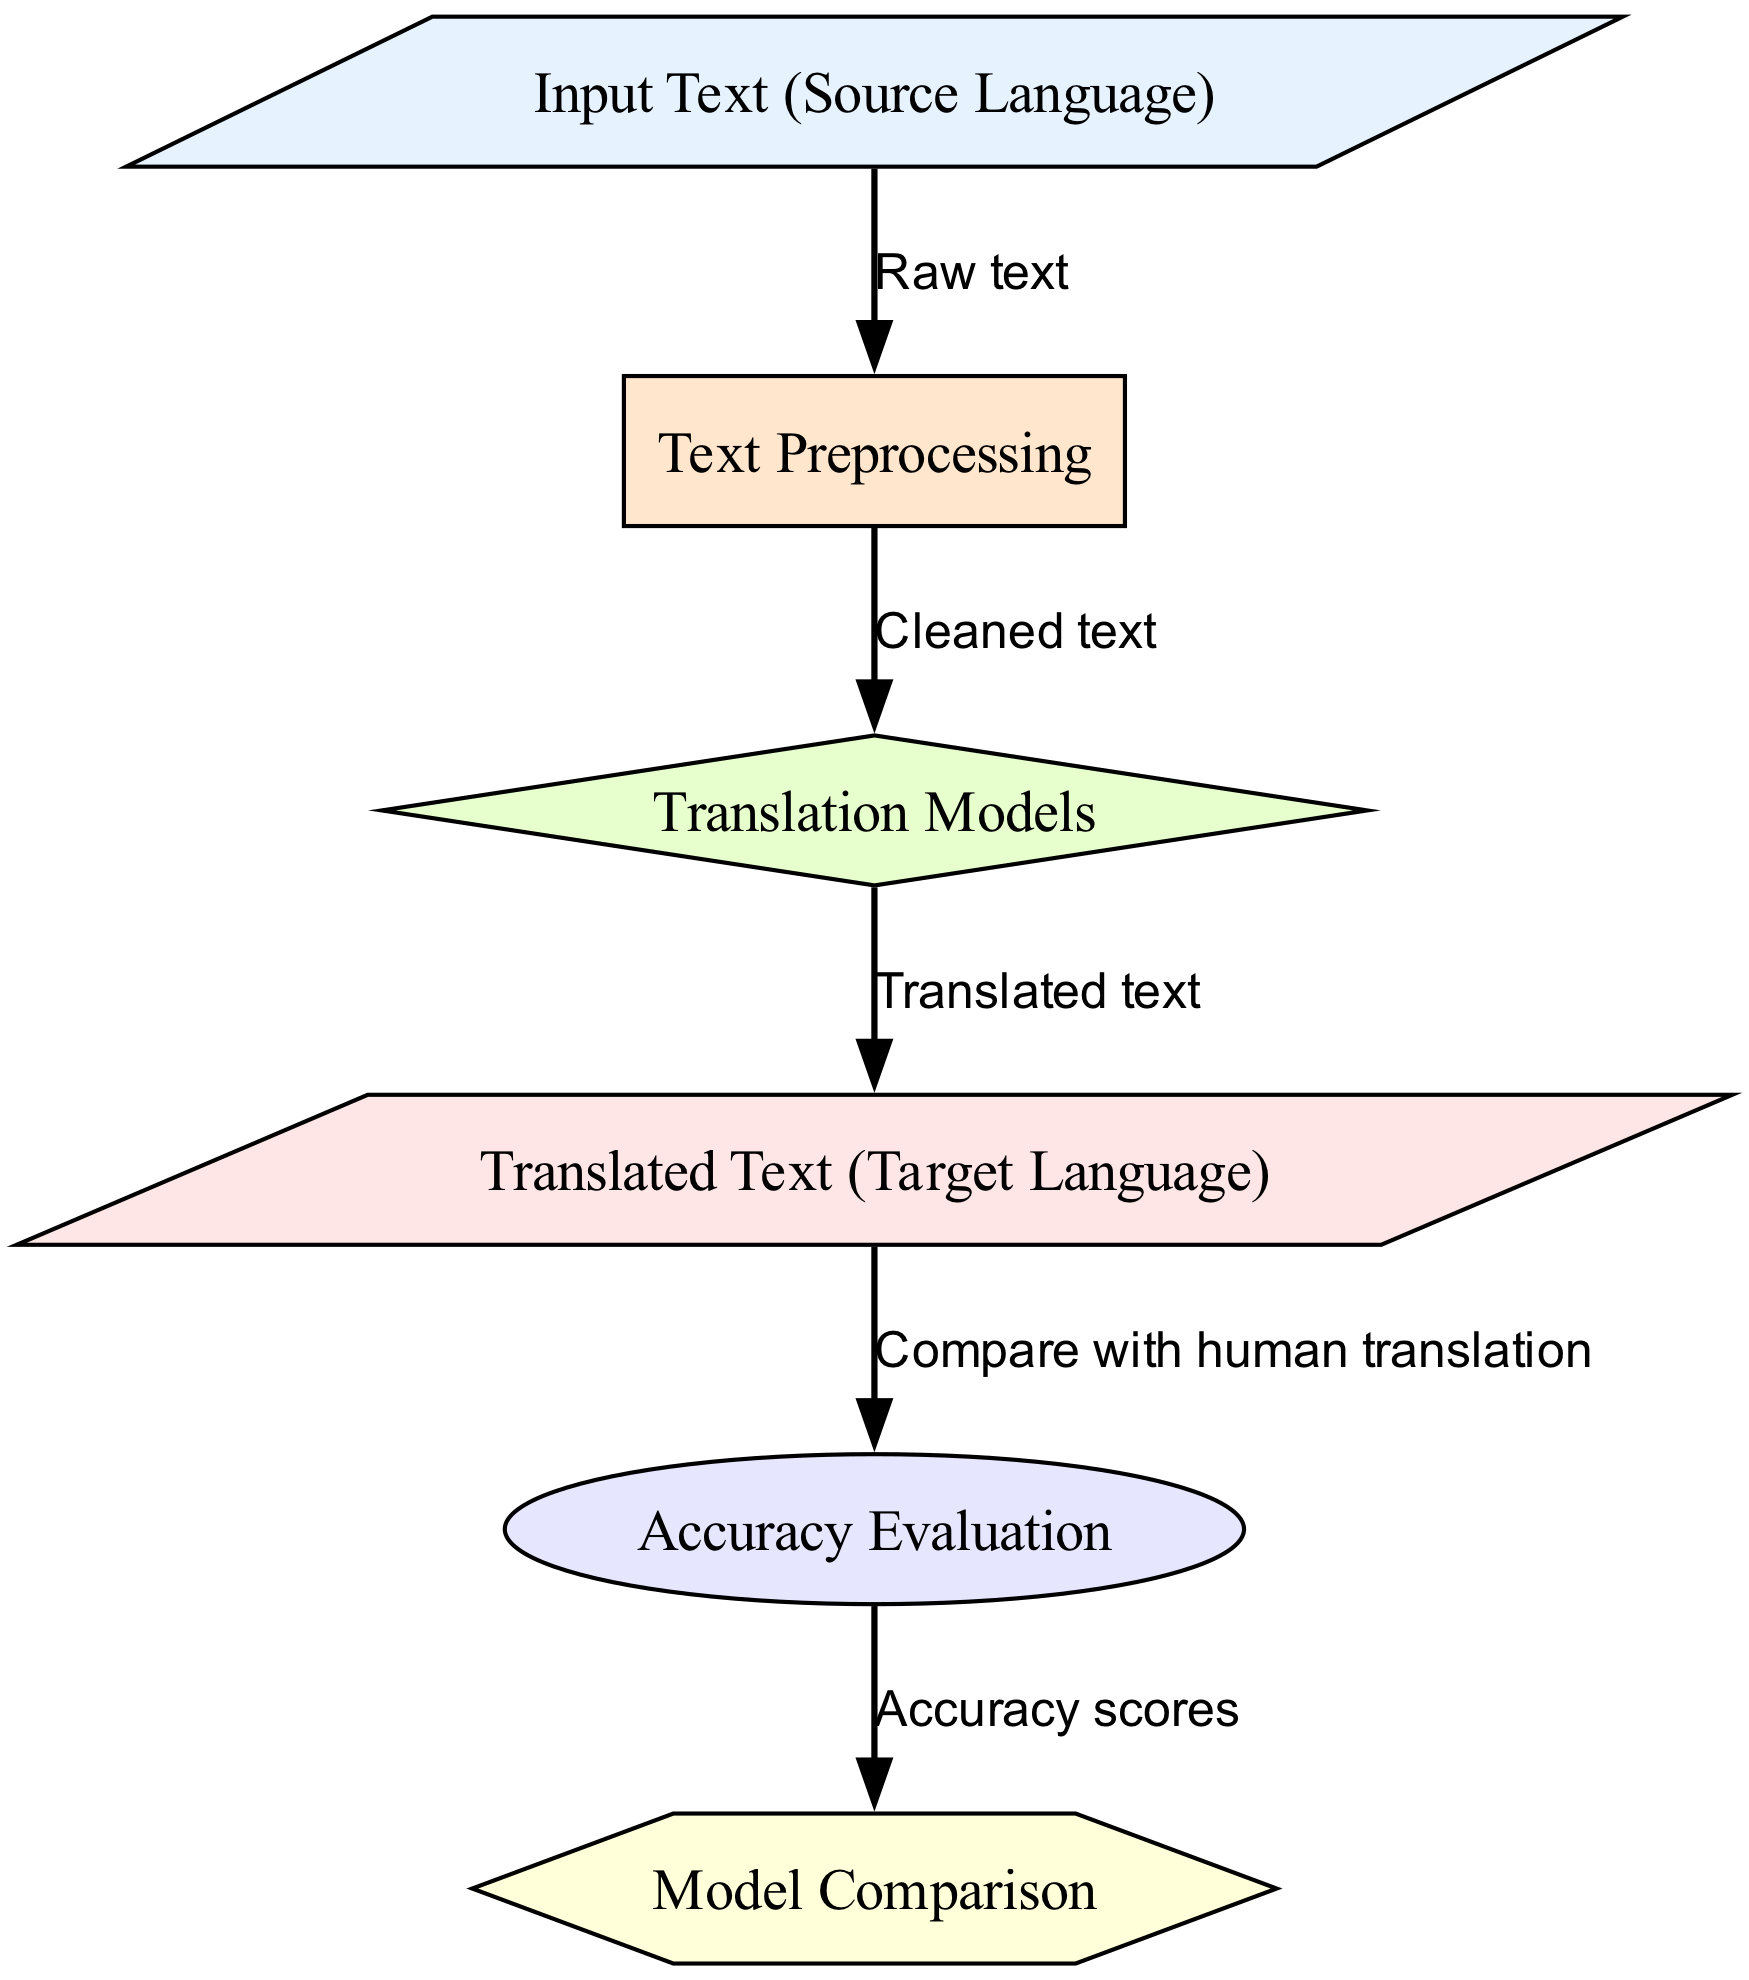What is the first step in the translation process? The diagram shows the flow starting from the "Input Text (Source Language)" node, which is the first step where raw text is input for processing.
Answer: Input Text (Source Language) How many nodes are depicted in the diagram? The diagram lists six nodes: Input Text, Text Preprocessing, Translation Models, Translated Text, Accuracy Evaluation, and Model Comparison, totaling six nodes.
Answer: Six What is the output of the translation models referred to as in the diagram? The edge leading from the "Translation Models" node points to the "Translated Text (Target Language)" node, indicating that this is the output of the translation models.
Answer: Translated Text (Target Language) What does the "Accuracy Evaluation" node compare with? Referring to the edge from the "Output Text" node to the "Accuracy Evaluation" node, it mentions "Compare with human translation," suggesting that the evaluation is based on comparison with human translations.
Answer: Human translation What type of node is "Model Comparison"? The diagram shape of the "Model Comparison" node is a hexagon, indicating that it is specifically classified as a hexagonal node in the visual representation.
Answer: Hexagon In what order does the process flow after the "Text Preprocessing"? After "Text Preprocessing," the flow goes to the "Translation Models" node, indicating this is the next step following preprocessing of the text.
Answer: Translation Models How are accuracy scores derived in this diagram? The "Accuracy Evaluation" node connects to the "Model Comparison" node, indicating that the accuracy scores come from the evaluation of the translation models, which are then compared for assessment.
Answer: Accuracy scores What is the relationship between "Translated Text" and "Accuracy Evaluation"? The edge labeled "Compare with human translation" connects the "Translated Text" node to the "Accuracy Evaluation" node, indicating that this relationship is centered on the evaluation process based on human translations.
Answer: Compare with human translation What is the purpose of the "Text Preprocessing" node? The diagram indicates that the "Text Preprocessing" node transforms "Raw text" into "Cleaned text," serving the purpose of preparing the input for translation.
Answer: Cleaned text 